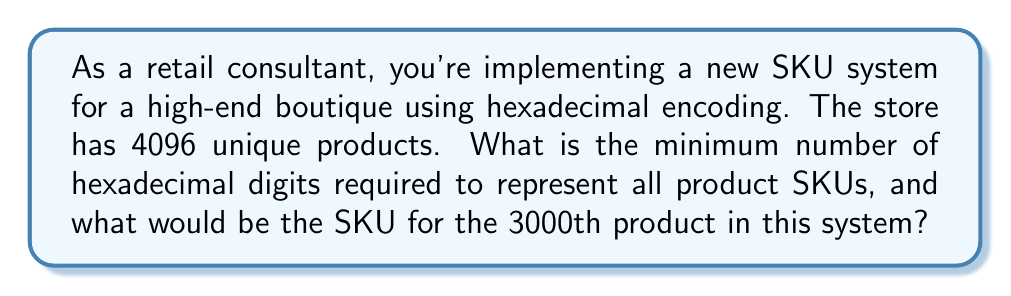Show me your answer to this math problem. 1) First, let's determine the minimum number of hexadecimal digits:

   - The store has 4096 unique products.
   - In hexadecimal, each digit can represent 16 values (0-9, A-F).
   - We need to find $n$ such that $16^n \geq 4096$

   $$16^3 = 4096$$

   Therefore, 3 hexadecimal digits are sufficient.

2) Now, let's encode the 3000th product:

   - Convert 3000 to hexadecimal:
     $$3000 \div 16 = 187 \text{ remainder } 8$$
     $$187 \div 16 = 11 \text{ remainder } 11$$
     $$11 \div 16 = 0 \text{ remainder } 11$$

   - Reading the remainders from bottom to top:
     11 (B in hex), 11 (B in hex), 8

   - Therefore, 3000 in hexadecimal is BB8.

3) Since we determined we need 3 digits, and BB8 already has 3 digits, this is our final SKU.
Answer: 3 digits; BB8 